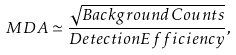<formula> <loc_0><loc_0><loc_500><loc_500>M D A \simeq \frac { \sqrt { B a c k g r o u n d C o u n t s } } { D e t e c t i o n E f f i c i e n c y } ,</formula> 